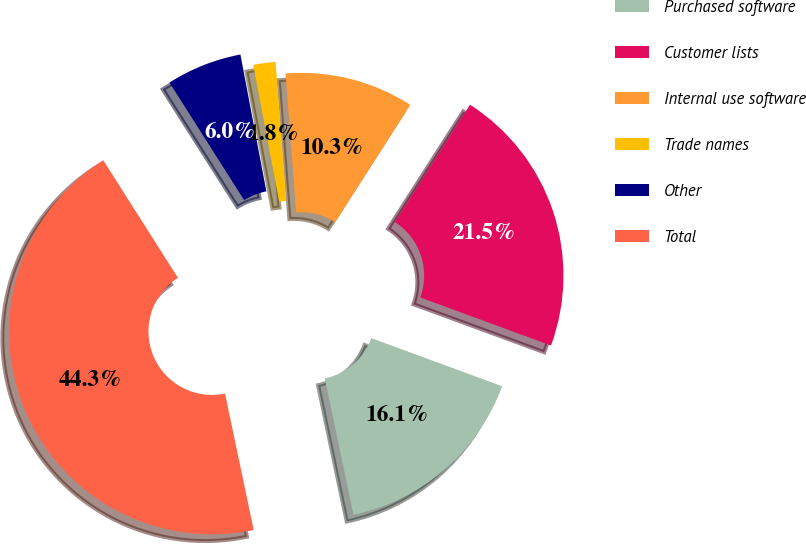Convert chart. <chart><loc_0><loc_0><loc_500><loc_500><pie_chart><fcel>Purchased software<fcel>Customer lists<fcel>Internal use software<fcel>Trade names<fcel>Other<fcel>Total<nl><fcel>16.1%<fcel>21.54%<fcel>10.28%<fcel>1.77%<fcel>6.02%<fcel>44.29%<nl></chart> 